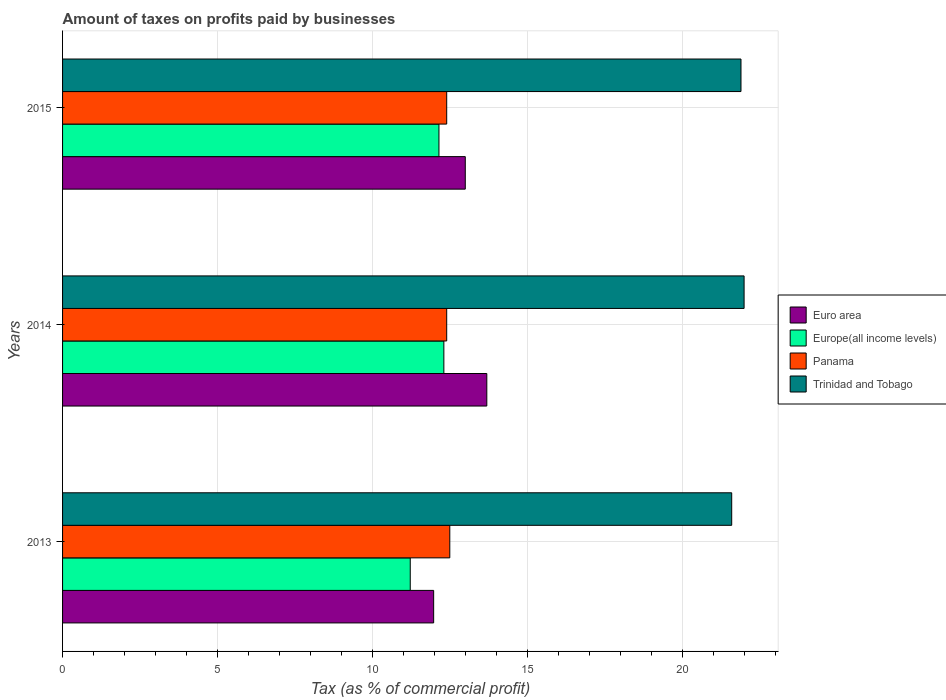How many groups of bars are there?
Ensure brevity in your answer.  3. What is the label of the 2nd group of bars from the top?
Your response must be concise. 2014. What is the percentage of taxes paid by businesses in Trinidad and Tobago in 2013?
Ensure brevity in your answer.  21.6. Across all years, what is the maximum percentage of taxes paid by businesses in Europe(all income levels)?
Give a very brief answer. 12.31. Across all years, what is the minimum percentage of taxes paid by businesses in Trinidad and Tobago?
Offer a terse response. 21.6. In which year was the percentage of taxes paid by businesses in Europe(all income levels) maximum?
Ensure brevity in your answer.  2014. What is the total percentage of taxes paid by businesses in Europe(all income levels) in the graph?
Provide a short and direct response. 35.68. What is the difference between the percentage of taxes paid by businesses in Trinidad and Tobago in 2013 and that in 2014?
Give a very brief answer. -0.4. What is the difference between the percentage of taxes paid by businesses in Euro area in 2014 and the percentage of taxes paid by businesses in Trinidad and Tobago in 2015?
Provide a short and direct response. -8.21. What is the average percentage of taxes paid by businesses in Trinidad and Tobago per year?
Your response must be concise. 21.83. In how many years, is the percentage of taxes paid by businesses in Panama greater than 3 %?
Ensure brevity in your answer.  3. What is the ratio of the percentage of taxes paid by businesses in Panama in 2013 to that in 2015?
Keep it short and to the point. 1.01. Is the percentage of taxes paid by businesses in Euro area in 2013 less than that in 2014?
Provide a succinct answer. Yes. Is the difference between the percentage of taxes paid by businesses in Panama in 2013 and 2014 greater than the difference between the percentage of taxes paid by businesses in Europe(all income levels) in 2013 and 2014?
Offer a terse response. Yes. What is the difference between the highest and the second highest percentage of taxes paid by businesses in Europe(all income levels)?
Your answer should be very brief. 0.16. What is the difference between the highest and the lowest percentage of taxes paid by businesses in Europe(all income levels)?
Your answer should be very brief. 1.08. In how many years, is the percentage of taxes paid by businesses in Europe(all income levels) greater than the average percentage of taxes paid by businesses in Europe(all income levels) taken over all years?
Offer a very short reply. 2. Is it the case that in every year, the sum of the percentage of taxes paid by businesses in Euro area and percentage of taxes paid by businesses in Panama is greater than the sum of percentage of taxes paid by businesses in Europe(all income levels) and percentage of taxes paid by businesses in Trinidad and Tobago?
Give a very brief answer. Yes. What does the 2nd bar from the top in 2013 represents?
Ensure brevity in your answer.  Panama. What does the 4th bar from the bottom in 2014 represents?
Provide a short and direct response. Trinidad and Tobago. Is it the case that in every year, the sum of the percentage of taxes paid by businesses in Panama and percentage of taxes paid by businesses in Europe(all income levels) is greater than the percentage of taxes paid by businesses in Euro area?
Your response must be concise. Yes. What is the difference between two consecutive major ticks on the X-axis?
Ensure brevity in your answer.  5. Does the graph contain any zero values?
Offer a very short reply. No. How many legend labels are there?
Offer a very short reply. 4. How are the legend labels stacked?
Ensure brevity in your answer.  Vertical. What is the title of the graph?
Give a very brief answer. Amount of taxes on profits paid by businesses. What is the label or title of the X-axis?
Your answer should be compact. Tax (as % of commercial profit). What is the label or title of the Y-axis?
Provide a short and direct response. Years. What is the Tax (as % of commercial profit) in Euro area in 2013?
Your response must be concise. 11.98. What is the Tax (as % of commercial profit) of Europe(all income levels) in 2013?
Give a very brief answer. 11.22. What is the Tax (as % of commercial profit) in Panama in 2013?
Provide a succinct answer. 12.5. What is the Tax (as % of commercial profit) of Trinidad and Tobago in 2013?
Your answer should be compact. 21.6. What is the Tax (as % of commercial profit) in Euro area in 2014?
Keep it short and to the point. 13.69. What is the Tax (as % of commercial profit) of Europe(all income levels) in 2014?
Give a very brief answer. 12.31. What is the Tax (as % of commercial profit) in Trinidad and Tobago in 2014?
Your answer should be very brief. 22. What is the Tax (as % of commercial profit) of Euro area in 2015?
Keep it short and to the point. 13. What is the Tax (as % of commercial profit) of Europe(all income levels) in 2015?
Provide a short and direct response. 12.15. What is the Tax (as % of commercial profit) in Panama in 2015?
Provide a succinct answer. 12.4. What is the Tax (as % of commercial profit) of Trinidad and Tobago in 2015?
Make the answer very short. 21.9. Across all years, what is the maximum Tax (as % of commercial profit) in Euro area?
Make the answer very short. 13.69. Across all years, what is the maximum Tax (as % of commercial profit) in Europe(all income levels)?
Make the answer very short. 12.31. Across all years, what is the maximum Tax (as % of commercial profit) of Panama?
Give a very brief answer. 12.5. Across all years, what is the maximum Tax (as % of commercial profit) in Trinidad and Tobago?
Your answer should be very brief. 22. Across all years, what is the minimum Tax (as % of commercial profit) in Euro area?
Offer a very short reply. 11.98. Across all years, what is the minimum Tax (as % of commercial profit) in Europe(all income levels)?
Ensure brevity in your answer.  11.22. Across all years, what is the minimum Tax (as % of commercial profit) in Trinidad and Tobago?
Make the answer very short. 21.6. What is the total Tax (as % of commercial profit) in Euro area in the graph?
Ensure brevity in your answer.  38.67. What is the total Tax (as % of commercial profit) in Europe(all income levels) in the graph?
Ensure brevity in your answer.  35.68. What is the total Tax (as % of commercial profit) in Panama in the graph?
Your response must be concise. 37.3. What is the total Tax (as % of commercial profit) of Trinidad and Tobago in the graph?
Offer a very short reply. 65.5. What is the difference between the Tax (as % of commercial profit) in Euro area in 2013 and that in 2014?
Give a very brief answer. -1.72. What is the difference between the Tax (as % of commercial profit) in Europe(all income levels) in 2013 and that in 2014?
Make the answer very short. -1.08. What is the difference between the Tax (as % of commercial profit) of Panama in 2013 and that in 2014?
Offer a terse response. 0.1. What is the difference between the Tax (as % of commercial profit) in Euro area in 2013 and that in 2015?
Your answer should be compact. -1.02. What is the difference between the Tax (as % of commercial profit) in Europe(all income levels) in 2013 and that in 2015?
Keep it short and to the point. -0.93. What is the difference between the Tax (as % of commercial profit) of Euro area in 2014 and that in 2015?
Provide a short and direct response. 0.69. What is the difference between the Tax (as % of commercial profit) in Europe(all income levels) in 2014 and that in 2015?
Your response must be concise. 0.16. What is the difference between the Tax (as % of commercial profit) in Euro area in 2013 and the Tax (as % of commercial profit) in Europe(all income levels) in 2014?
Provide a short and direct response. -0.33. What is the difference between the Tax (as % of commercial profit) in Euro area in 2013 and the Tax (as % of commercial profit) in Panama in 2014?
Provide a succinct answer. -0.42. What is the difference between the Tax (as % of commercial profit) of Euro area in 2013 and the Tax (as % of commercial profit) of Trinidad and Tobago in 2014?
Give a very brief answer. -10.02. What is the difference between the Tax (as % of commercial profit) in Europe(all income levels) in 2013 and the Tax (as % of commercial profit) in Panama in 2014?
Your answer should be very brief. -1.18. What is the difference between the Tax (as % of commercial profit) in Europe(all income levels) in 2013 and the Tax (as % of commercial profit) in Trinidad and Tobago in 2014?
Ensure brevity in your answer.  -10.78. What is the difference between the Tax (as % of commercial profit) in Panama in 2013 and the Tax (as % of commercial profit) in Trinidad and Tobago in 2014?
Ensure brevity in your answer.  -9.5. What is the difference between the Tax (as % of commercial profit) in Euro area in 2013 and the Tax (as % of commercial profit) in Europe(all income levels) in 2015?
Offer a terse response. -0.17. What is the difference between the Tax (as % of commercial profit) of Euro area in 2013 and the Tax (as % of commercial profit) of Panama in 2015?
Make the answer very short. -0.42. What is the difference between the Tax (as % of commercial profit) in Euro area in 2013 and the Tax (as % of commercial profit) in Trinidad and Tobago in 2015?
Keep it short and to the point. -9.92. What is the difference between the Tax (as % of commercial profit) of Europe(all income levels) in 2013 and the Tax (as % of commercial profit) of Panama in 2015?
Ensure brevity in your answer.  -1.18. What is the difference between the Tax (as % of commercial profit) in Europe(all income levels) in 2013 and the Tax (as % of commercial profit) in Trinidad and Tobago in 2015?
Keep it short and to the point. -10.68. What is the difference between the Tax (as % of commercial profit) of Panama in 2013 and the Tax (as % of commercial profit) of Trinidad and Tobago in 2015?
Provide a short and direct response. -9.4. What is the difference between the Tax (as % of commercial profit) in Euro area in 2014 and the Tax (as % of commercial profit) in Europe(all income levels) in 2015?
Your response must be concise. 1.54. What is the difference between the Tax (as % of commercial profit) in Euro area in 2014 and the Tax (as % of commercial profit) in Panama in 2015?
Provide a succinct answer. 1.29. What is the difference between the Tax (as % of commercial profit) of Euro area in 2014 and the Tax (as % of commercial profit) of Trinidad and Tobago in 2015?
Ensure brevity in your answer.  -8.21. What is the difference between the Tax (as % of commercial profit) in Europe(all income levels) in 2014 and the Tax (as % of commercial profit) in Panama in 2015?
Your answer should be very brief. -0.09. What is the difference between the Tax (as % of commercial profit) of Europe(all income levels) in 2014 and the Tax (as % of commercial profit) of Trinidad and Tobago in 2015?
Provide a succinct answer. -9.59. What is the average Tax (as % of commercial profit) of Euro area per year?
Offer a very short reply. 12.89. What is the average Tax (as % of commercial profit) of Europe(all income levels) per year?
Your answer should be compact. 11.89. What is the average Tax (as % of commercial profit) of Panama per year?
Offer a very short reply. 12.43. What is the average Tax (as % of commercial profit) of Trinidad and Tobago per year?
Provide a short and direct response. 21.83. In the year 2013, what is the difference between the Tax (as % of commercial profit) in Euro area and Tax (as % of commercial profit) in Europe(all income levels)?
Keep it short and to the point. 0.76. In the year 2013, what is the difference between the Tax (as % of commercial profit) in Euro area and Tax (as % of commercial profit) in Panama?
Your answer should be compact. -0.52. In the year 2013, what is the difference between the Tax (as % of commercial profit) of Euro area and Tax (as % of commercial profit) of Trinidad and Tobago?
Your answer should be compact. -9.62. In the year 2013, what is the difference between the Tax (as % of commercial profit) in Europe(all income levels) and Tax (as % of commercial profit) in Panama?
Your answer should be compact. -1.28. In the year 2013, what is the difference between the Tax (as % of commercial profit) in Europe(all income levels) and Tax (as % of commercial profit) in Trinidad and Tobago?
Your response must be concise. -10.38. In the year 2014, what is the difference between the Tax (as % of commercial profit) of Euro area and Tax (as % of commercial profit) of Europe(all income levels)?
Offer a terse response. 1.39. In the year 2014, what is the difference between the Tax (as % of commercial profit) in Euro area and Tax (as % of commercial profit) in Panama?
Provide a short and direct response. 1.29. In the year 2014, what is the difference between the Tax (as % of commercial profit) in Euro area and Tax (as % of commercial profit) in Trinidad and Tobago?
Ensure brevity in your answer.  -8.31. In the year 2014, what is the difference between the Tax (as % of commercial profit) of Europe(all income levels) and Tax (as % of commercial profit) of Panama?
Your answer should be very brief. -0.09. In the year 2014, what is the difference between the Tax (as % of commercial profit) of Europe(all income levels) and Tax (as % of commercial profit) of Trinidad and Tobago?
Your answer should be very brief. -9.69. In the year 2014, what is the difference between the Tax (as % of commercial profit) of Panama and Tax (as % of commercial profit) of Trinidad and Tobago?
Give a very brief answer. -9.6. In the year 2015, what is the difference between the Tax (as % of commercial profit) in Euro area and Tax (as % of commercial profit) in Europe(all income levels)?
Provide a short and direct response. 0.85. In the year 2015, what is the difference between the Tax (as % of commercial profit) in Europe(all income levels) and Tax (as % of commercial profit) in Trinidad and Tobago?
Your response must be concise. -9.75. What is the ratio of the Tax (as % of commercial profit) of Euro area in 2013 to that in 2014?
Offer a very short reply. 0.87. What is the ratio of the Tax (as % of commercial profit) in Europe(all income levels) in 2013 to that in 2014?
Your response must be concise. 0.91. What is the ratio of the Tax (as % of commercial profit) of Panama in 2013 to that in 2014?
Your answer should be compact. 1.01. What is the ratio of the Tax (as % of commercial profit) of Trinidad and Tobago in 2013 to that in 2014?
Provide a succinct answer. 0.98. What is the ratio of the Tax (as % of commercial profit) of Euro area in 2013 to that in 2015?
Provide a short and direct response. 0.92. What is the ratio of the Tax (as % of commercial profit) of Europe(all income levels) in 2013 to that in 2015?
Provide a short and direct response. 0.92. What is the ratio of the Tax (as % of commercial profit) in Trinidad and Tobago in 2013 to that in 2015?
Give a very brief answer. 0.99. What is the ratio of the Tax (as % of commercial profit) in Euro area in 2014 to that in 2015?
Provide a short and direct response. 1.05. What is the ratio of the Tax (as % of commercial profit) of Panama in 2014 to that in 2015?
Give a very brief answer. 1. What is the difference between the highest and the second highest Tax (as % of commercial profit) in Euro area?
Offer a very short reply. 0.69. What is the difference between the highest and the second highest Tax (as % of commercial profit) of Europe(all income levels)?
Provide a short and direct response. 0.16. What is the difference between the highest and the second highest Tax (as % of commercial profit) in Panama?
Your response must be concise. 0.1. What is the difference between the highest and the lowest Tax (as % of commercial profit) of Euro area?
Make the answer very short. 1.72. What is the difference between the highest and the lowest Tax (as % of commercial profit) of Europe(all income levels)?
Your answer should be compact. 1.08. What is the difference between the highest and the lowest Tax (as % of commercial profit) of Panama?
Provide a succinct answer. 0.1. What is the difference between the highest and the lowest Tax (as % of commercial profit) in Trinidad and Tobago?
Your response must be concise. 0.4. 